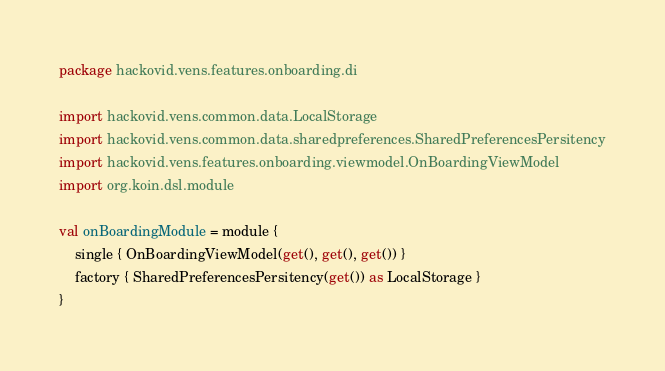Convert code to text. <code><loc_0><loc_0><loc_500><loc_500><_Kotlin_>package hackovid.vens.features.onboarding.di

import hackovid.vens.common.data.LocalStorage
import hackovid.vens.common.data.sharedpreferences.SharedPreferencesPersitency
import hackovid.vens.features.onboarding.viewmodel.OnBoardingViewModel
import org.koin.dsl.module

val onBoardingModule = module {
    single { OnBoardingViewModel(get(), get(), get()) }
    factory { SharedPreferencesPersitency(get()) as LocalStorage }
}
</code> 